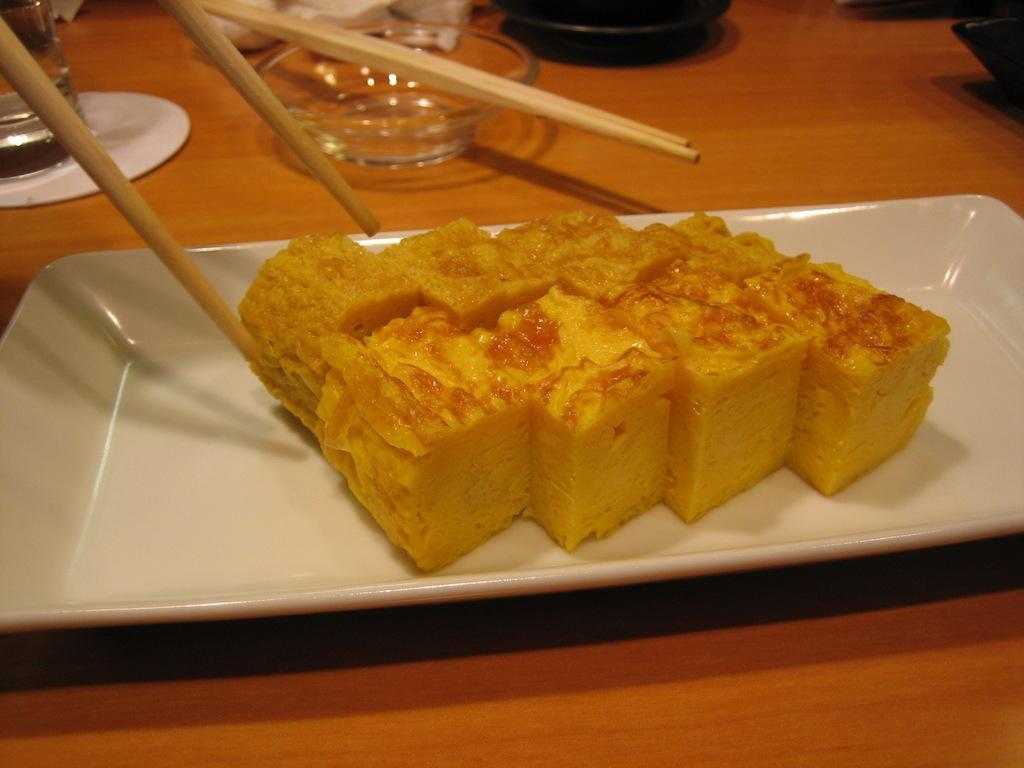How would you summarize this image in a sentence or two? In this image there is a table and on top of it there is a plate and a food in it and there is a bowl, a glass and a chopsticks were there on it. 